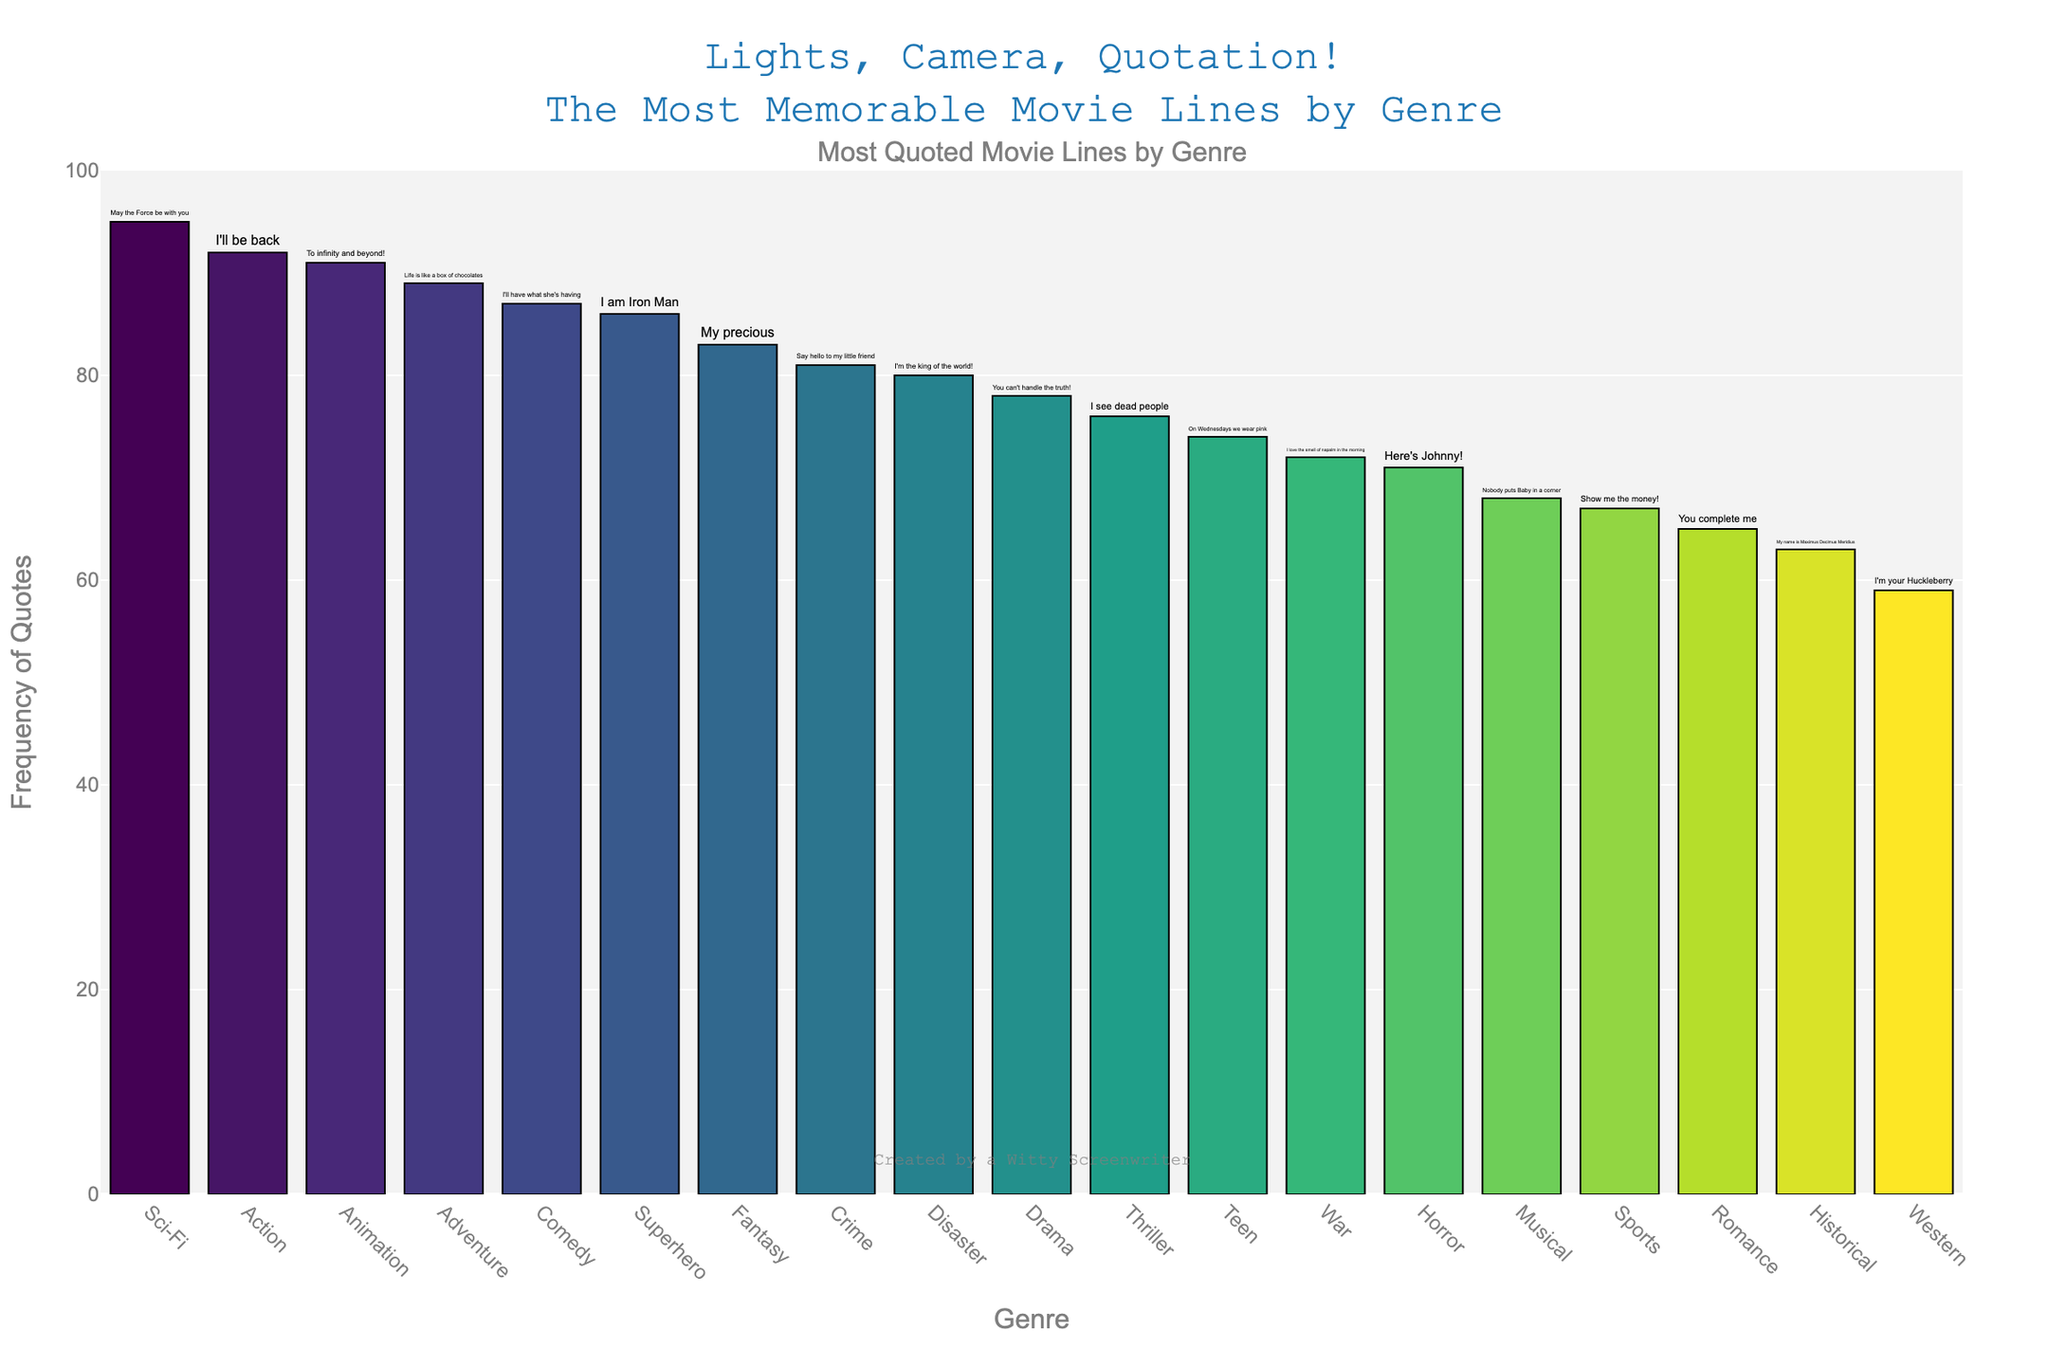What's the most quoted movie line in the Comedy genre? The height of the bar for Comedy genre represents the frequency, and the text associated with that bar shows the most quoted line, which is "I'll have what she's having".
Answer: "I'll have what she's having" Which genre has the quote with the lowest frequency? By comparing the heights of all the bars, the Western genre has the lowest bar with a frequency, indicating the quote "I'm your Huckleberry" frequency is the smallest.
Answer: Western How many quotes have a frequency higher than 80? By looking at the heights of the bars and their associated frequencies, the genres with frequencies higher than 80 are Action (92), Sci-Fi (95), Adventure (89), Animation (91), Comedy (87), Fantasy (83), Crime (81), and Superhero (86). Counting these, there are 8 quotes.
Answer: 8 Which quote is more frequently quoted: "You complete me" or "I'm the king of the world"? Comparing the heights of the bars for Romance ("You complete me") and Disaster ("I'm the king of the world"), Disaster has a higher frequency of 80 compared to Romance which has a frequency of 65.
Answer: "I'm the king of the world" What's the sum of the frequencies of the quotes in the Sci-Fi and Adventure genres? The frequency for Sci-Fi is 95 and for Adventure is 89. Adding these together, the sum is 95 + 89 = 184.
Answer: 184 What is the average frequency of the quotes in the Comedy, Drama, and Horror genres? The frequencies for Comedy, Drama, and Horror are 87, 78, and 71 respectively. The average is calculated as (87 + 78 + 71) / 3 = 236 / 3 ≈ 78.67.
Answer: 78.67 Which genre has a more quoted line: Historical or Thriller? Comparing the heights of the bars for Historical ("My name is Maximus Decimus Meridius") and Thriller ("I see dead people"), Thriller has a frequency of 76, which is higher than Historical's 63.
Answer: Thriller Is the quote "I am Iron Man" from the Superhero genre quoted more frequently than "Say hello to my little friend" from the Crime genre? By looking at the heights of the bars for Superhero (86) and Crime (81), it's clear that "I am Iron Man" has a higher frequency.
Answer: Yes What are the top three genres with the most frequently quoted lines? By comparing the heights of all the bars, the Sci-Fi (95), Action (92), and Animation (91) genres have the three highest frequencies.
Answer: Sci-Fi, Action, Animation 